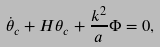Convert formula to latex. <formula><loc_0><loc_0><loc_500><loc_500>\dot { \theta } _ { c } + H \theta _ { c } + \frac { k ^ { 2 } } { a } \Phi = 0 ,</formula> 